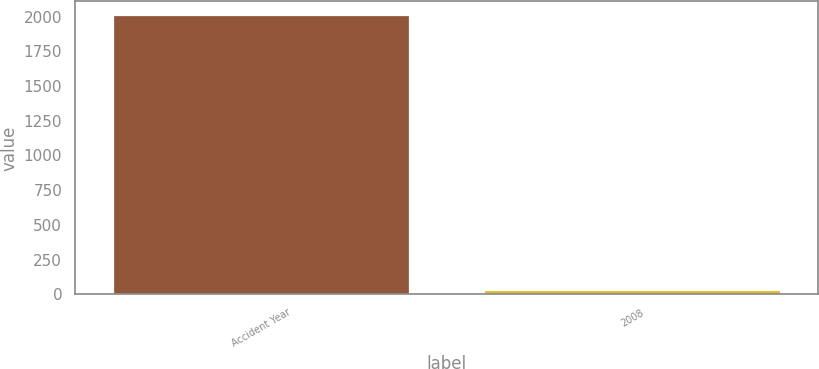<chart> <loc_0><loc_0><loc_500><loc_500><bar_chart><fcel>Accident Year<fcel>2008<nl><fcel>2008<fcel>31<nl></chart> 